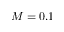Convert formula to latex. <formula><loc_0><loc_0><loc_500><loc_500>M = 0 . 1</formula> 